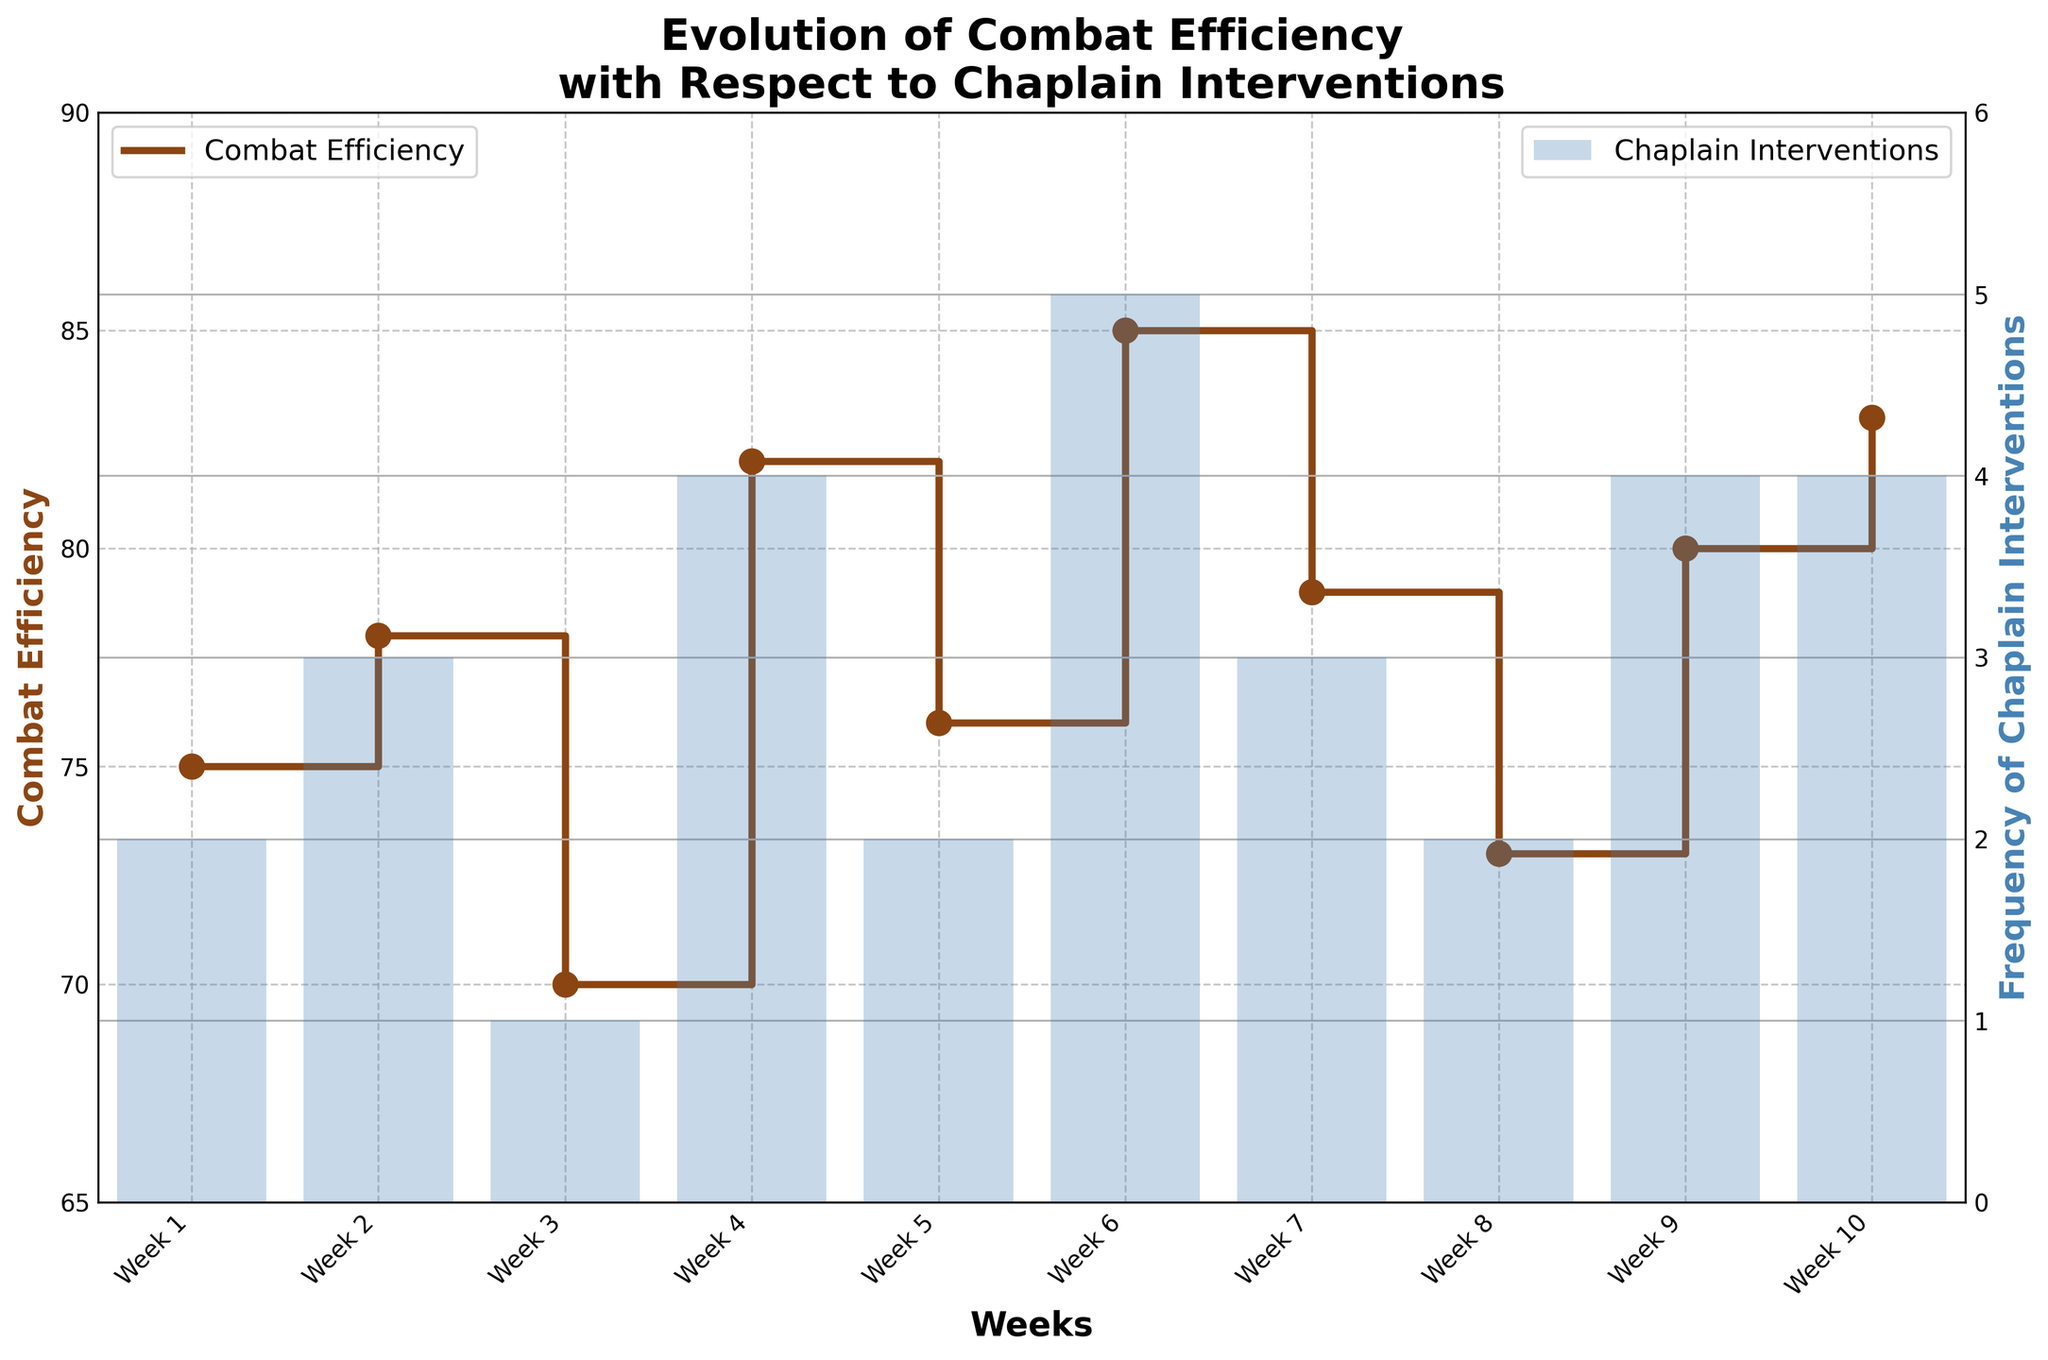What is the title of the figure? The title of the figure is displayed at the top of the plot. It reflects the main subject of the data visualization. The title states, "Evolution of Combat Efficiency with Respect to Chaplain Interventions."
Answer: Evolution of Combat Efficiency with Respect to Chaplain Interventions Which week shows the highest combat efficiency? To find the highest combat efficiency, look at the step plot line representing combat efficiency and identify the peak value. The highest point on the combat efficiency line corresponds to Week 6.
Answer: Week 6 In which weeks were the chaplain interventions at their highest frequency? Chaplain interventions are represented by the bar chart. The highest bars indicating the frequency of chaplain interventions reach their peak values at 5 interventions in Week 6.
Answer: Week 6 What is the combat efficiency in Week 3? Locate Week 3 on the x-axis and find the corresponding point on the step plot line for combat efficiency, which shows the value of 70.
Answer: 70 Which week experienced the greatest increase in combat efficiency? To identify the greatest increase, compare the differences between each week's combat efficiency. The largest jump is between Week 3 (70) and Week 4 (82).
Answer: Between Week 3 and Week 4 What is the average combat efficiency over the 10 weeks? Add all the combat efficiency values and divide by the number of weeks: (75 + 78 + 70 + 82 + 76 + 85 + 79 + 73 + 80 + 83) / 10 = 78.1.
Answer: 78.1 How does combat efficiency in Week 8 compare to Week 2? Compare the efficiency values for each week. Week 8 has a combat efficiency of 73, which is lower than Week 2's 78.
Answer: Week 8 is lower Is there a correlation between the number of chaplain interventions and combat efficiency? Compare the trends in both the step plot line and the bar chart visually. Generally, weeks with higher chaplain interventions tend to show higher combat efficiency, suggesting a positive correlation.
Answer: Positive correlation What trend do you observe in combat efficiency after Week 5? Observe the combat efficiency values from Week 6 onwards. The trend shows an increase: Week 6 (85), Week 7 (79), Week 8 (73), Week 9 (80), Week 10 (83).
Answer: Increasing then fluctuating How often did the frequency of chaplain interventions equal 4? Count the number of times bars reach the level of 4 on the y2-axis. The frequency of chaplain interventions was exactly 4 during Week 4, Week 9, and Week 10, so it occurred three times.
Answer: 3 times 